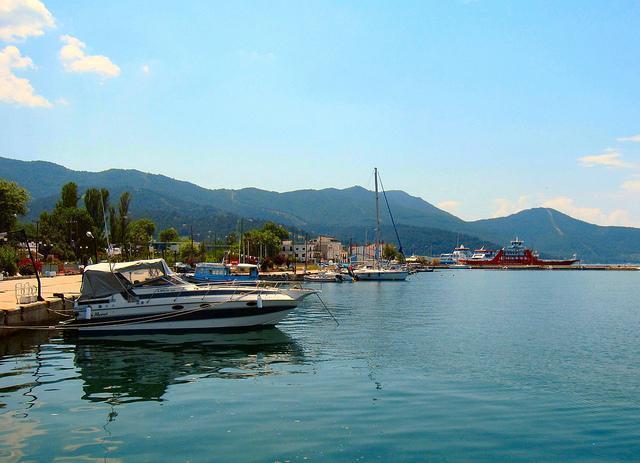What can usually be found in this setting?
Choose the correct response, then elucidate: 'Answer: answer
Rationale: rationale.'
Options: Tigers, camels, horses, fish. Answer: fish.
Rationale: Fish can be found in the water. 